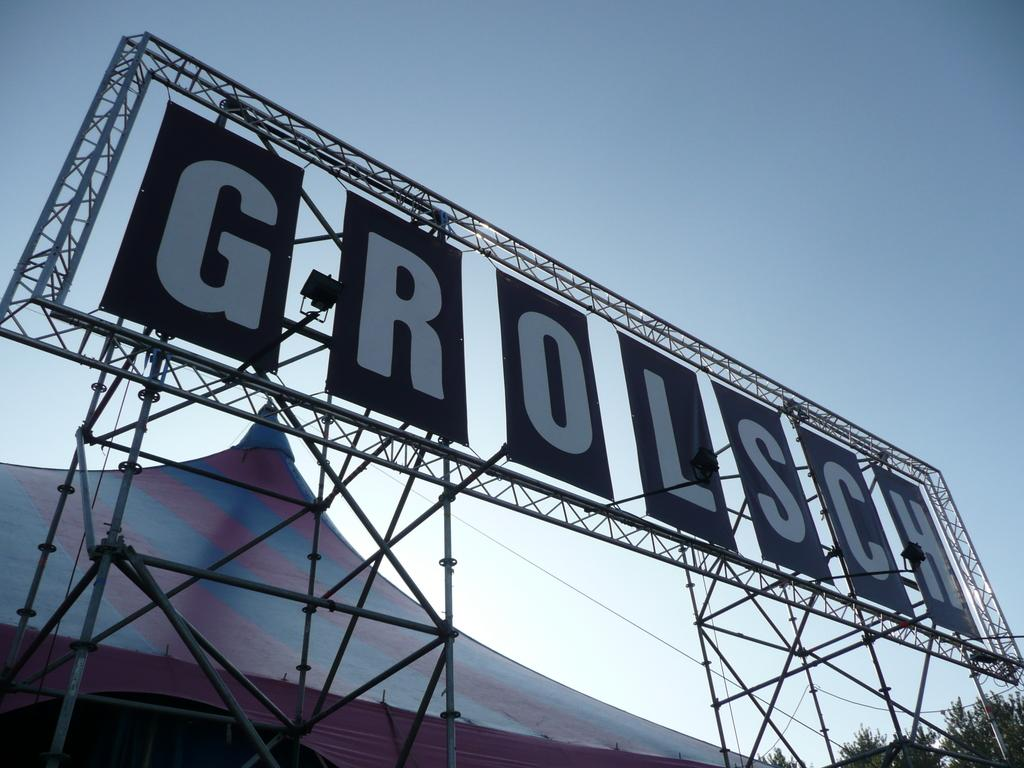<image>
Offer a succinct explanation of the picture presented. a large wire sign with the word GROLSCH on it 